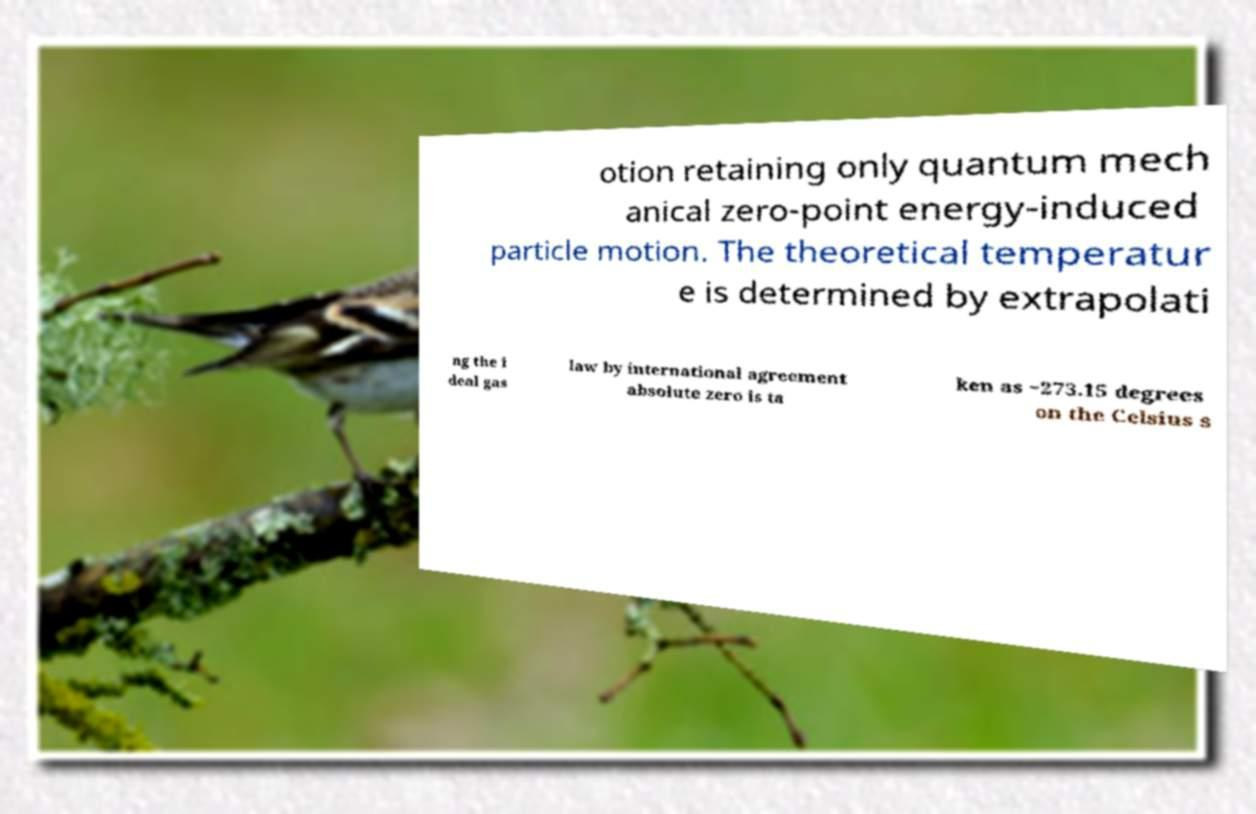I need the written content from this picture converted into text. Can you do that? otion retaining only quantum mech anical zero-point energy-induced particle motion. The theoretical temperatur e is determined by extrapolati ng the i deal gas law by international agreement absolute zero is ta ken as −273.15 degrees on the Celsius s 